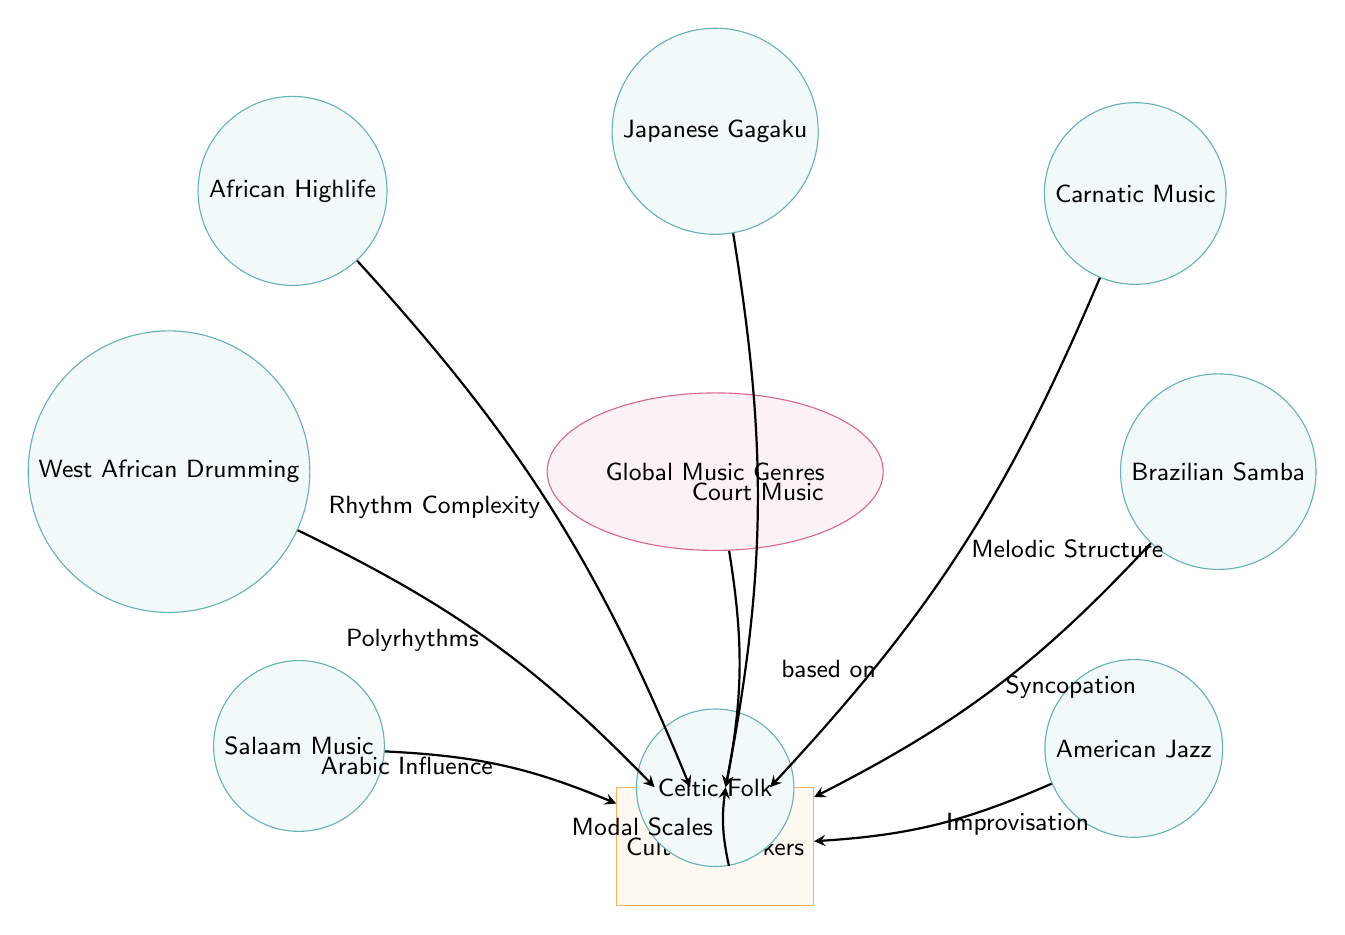What is the central node of the diagram? The diagram clearly marks the central node as "Global Music Genres," which serves as the main focus around which the other genres and cultural markers are organized.
Answer: Global Music Genres How many music genres are represented in the diagram? By counting the genre nodes surrounding the central node, we find a total of eight distinct music genres listed: African Highlife, West African Drumming, Salaam Music, Carnatic Music, Brazilian Samba, American Jazz, Japanese Gagaku, and Celtic Folk.
Answer: 8 What cultural marker is associated with African Highlife? The arrow from African Highlife points directly to the cultural marker labeled "Rhythm Complexity," indicating the specific cultural characteristic linked to this music genre.
Answer: Rhythm Complexity Which two genres are linked to the same cultural marker? By examining the arrows, we see that both West African Drumming and Salaam Music are connected to the cultural marker "Polyrhythms," showing a shared cultural aspect between these two genres.
Answer: West African Drumming and Salaam Music What is the cultural marker associated with American Jazz? The diagram indicates that American Jazz is linked to the cultural marker "Improvisation," showing this genre's distinct feature as represented in the visual layout.
Answer: Improvisation Which music genre is related to Malodic Structure? The diagram directly associates the cultural marker "Melodic Structure" with the genre "Carnatic Music," reflecting the unique musical characteristics of this genre.
Answer: Carnatic Music What is the relationship between Brazilian Samba and Syncopation? The arrow represents a direct connection from Brazilian Samba to the cultural marker "Syncopation," indicating that this rhythmic style is a defining characteristic of this genre.
Answer: Syncopation Which genre is influenced by Arabic markers? The arrow leading from Salaam Music points to the cultural influence labeled "Arabic Influence," indicating that this genre derives cultural elements from Arabic traditions.
Answer: Salaam Music How many cultural markers are listed in the diagram? The only cultural markers illustrated in the diagram are captured under a single node labeled "Cultural Markers," and analyzing the context of the diagram does not specify multiple cultural markers.
Answer: 1 